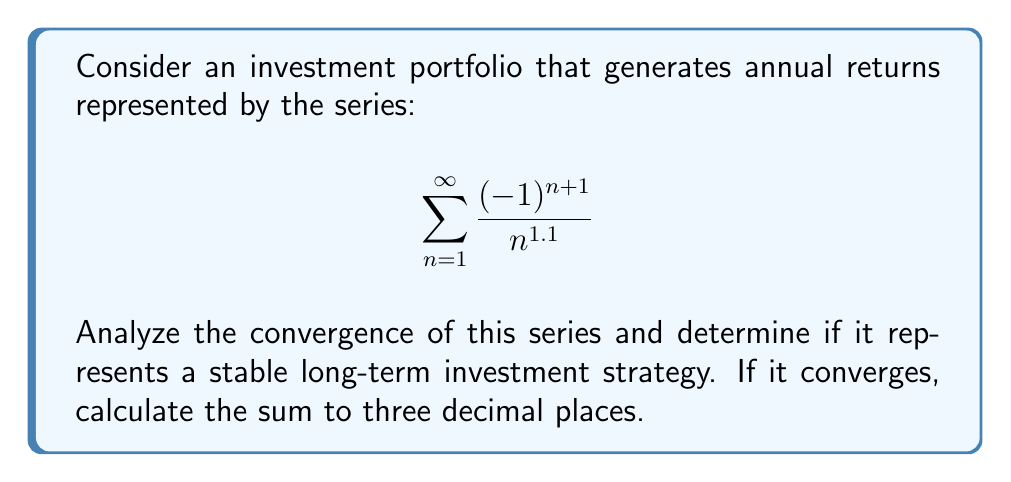Teach me how to tackle this problem. Let's approach this step-by-step:

1) First, we need to identify the type of series. This is an alternating series of the form $\sum_{n=1}^{\infty} (-1)^{n+1} a_n$ where $a_n = \frac{1}{n^{1.1}}$.

2) To analyze convergence, we can use the alternating series test (also known as Leibniz test). The conditions are:

   a) $a_n > a_{n+1}$ for all $n$ (decreasing)
   b) $\lim_{n \to \infty} a_n = 0$

3) Let's check condition (a):
   $a_n = \frac{1}{n^{1.1}}$ and $a_{n+1} = \frac{1}{(n+1)^{1.1}}$
   Clearly, $\frac{1}{n^{1.1}} > \frac{1}{(n+1)^{1.1}}$ for all $n$, so this condition is satisfied.

4) For condition (b):
   $\lim_{n \to \infty} \frac{1}{n^{1.1}} = 0$
   This condition is also satisfied.

5) Since both conditions are met, the series converges by the alternating series test.

6) To calculate the sum to three decimal places, we can use the alternating series estimation theorem. This states that the error in stopping at the $n$th term is less than the absolute value of the $(n+1)$th term.

7) Let's sum the series until the error is less than 0.0005:

   $S_1 = 1$
   $S_2 = 1 - 0.466 = 0.534$
   $S_3 = 0.534 + 0.316 = 0.850$
   $S_4 = 0.850 - 0.238 = 0.612$
   $S_5 = 0.612 + 0.191 = 0.803$

   The next term would be $\frac{1}{6^{1.1}} \approx 0.158$, which is less than 0.0005.

Therefore, the sum of the series to three decimal places is 0.803.
Answer: Converges; sum ≈ 0.803 